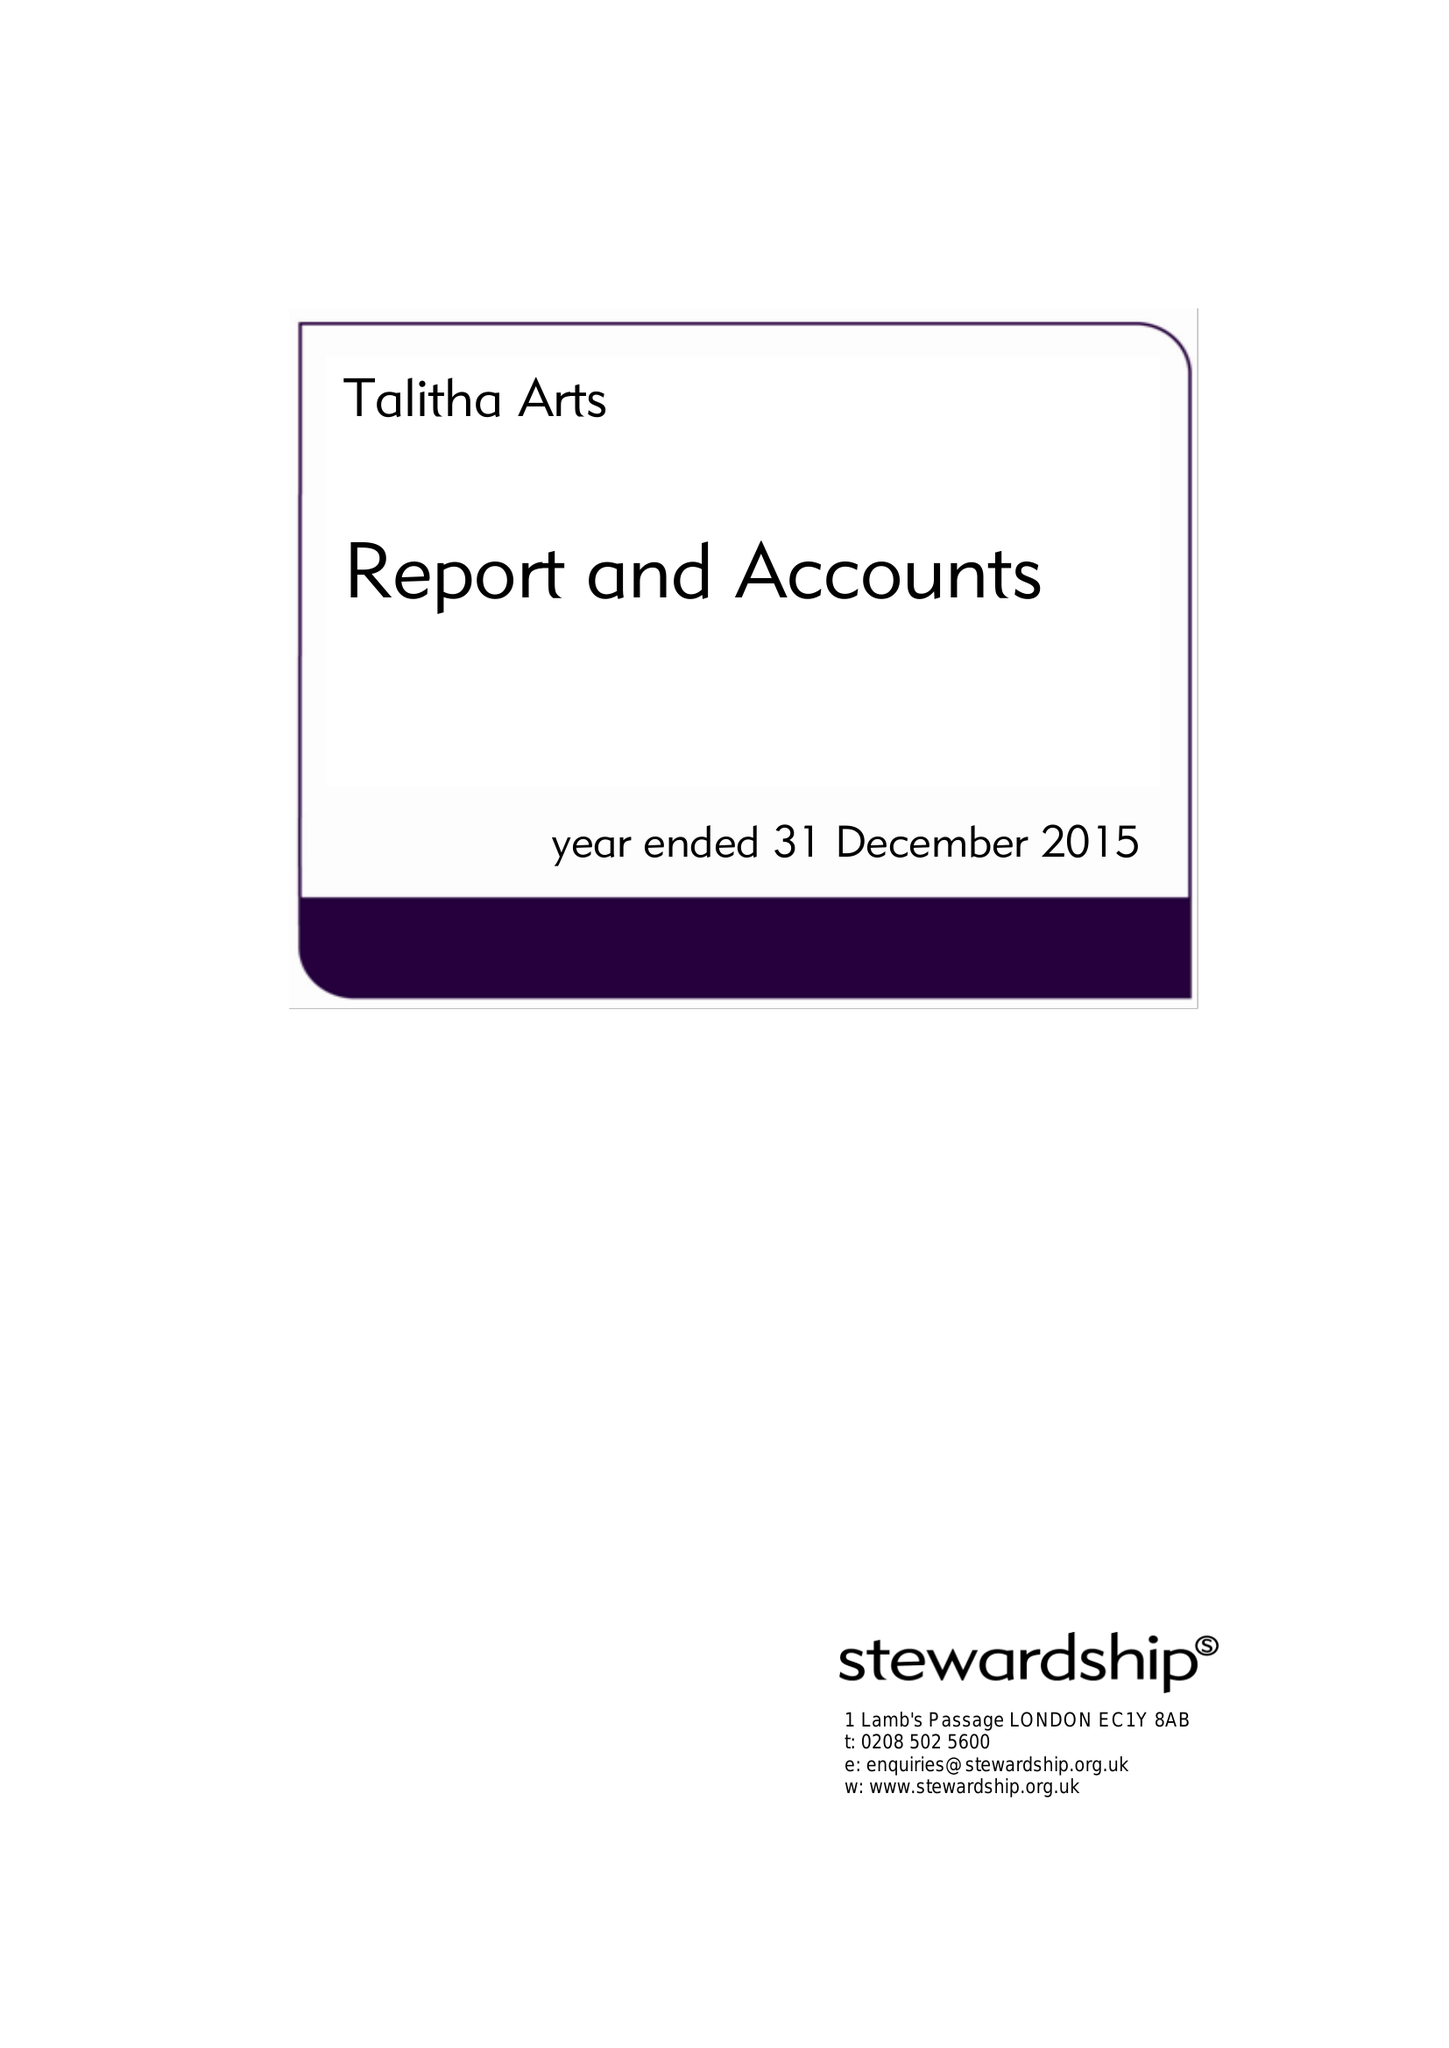What is the value for the spending_annually_in_british_pounds?
Answer the question using a single word or phrase. 27966.00 